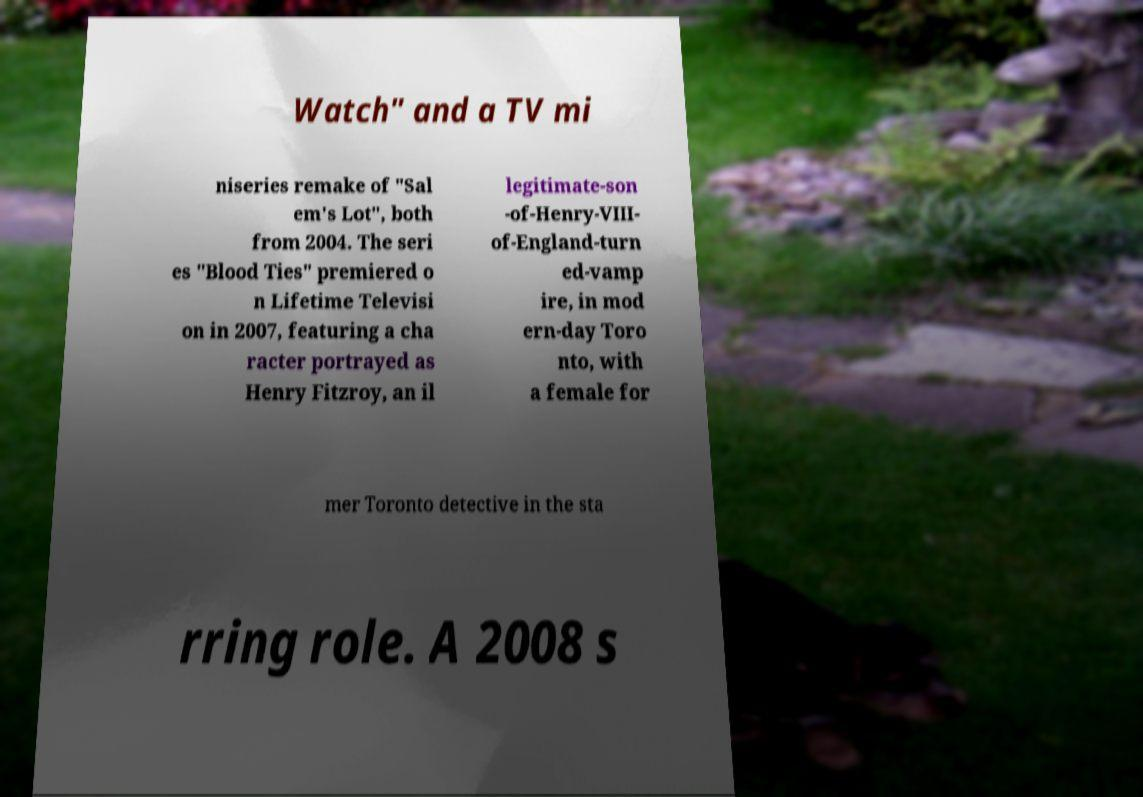For documentation purposes, I need the text within this image transcribed. Could you provide that? Watch" and a TV mi niseries remake of "Sal em's Lot", both from 2004. The seri es "Blood Ties" premiered o n Lifetime Televisi on in 2007, featuring a cha racter portrayed as Henry Fitzroy, an il legitimate-son -of-Henry-VIII- of-England-turn ed-vamp ire, in mod ern-day Toro nto, with a female for mer Toronto detective in the sta rring role. A 2008 s 